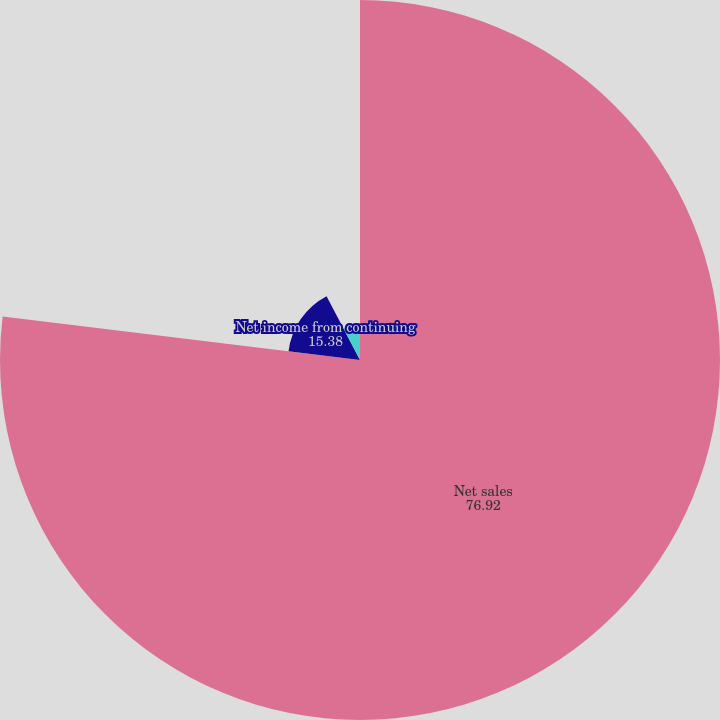<chart> <loc_0><loc_0><loc_500><loc_500><pie_chart><fcel>Net sales<fcel>Net income from continuing<fcel>Basic<fcel>Diluted<nl><fcel>76.92%<fcel>15.38%<fcel>7.69%<fcel>0.0%<nl></chart> 